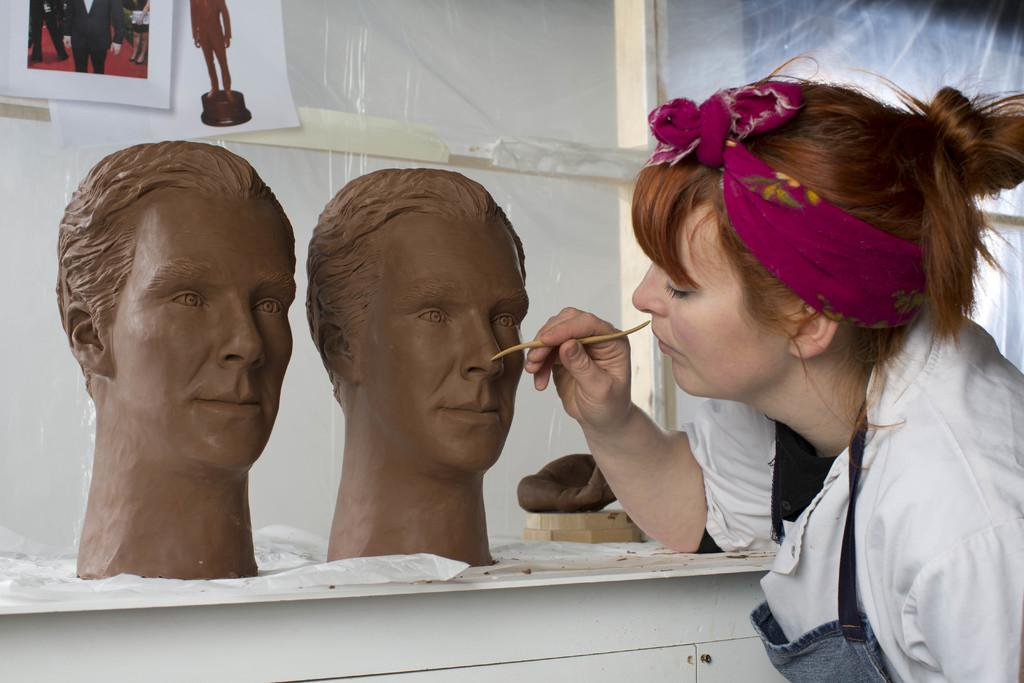Who is the main subject in the image? There is a woman in the image. Where is the woman located in the image? The woman is on the right side of the image. What is the woman wearing? The woman is wearing a white dress. What is the woman doing in the image? The woman is carving statues of two men's faces on a table. What can be seen on the wall behind the table? There are photographs on the wall behind the table. Where is the shelf with the rock and drawer located in the image? There is no shelf, rock, or drawer present in the image. 